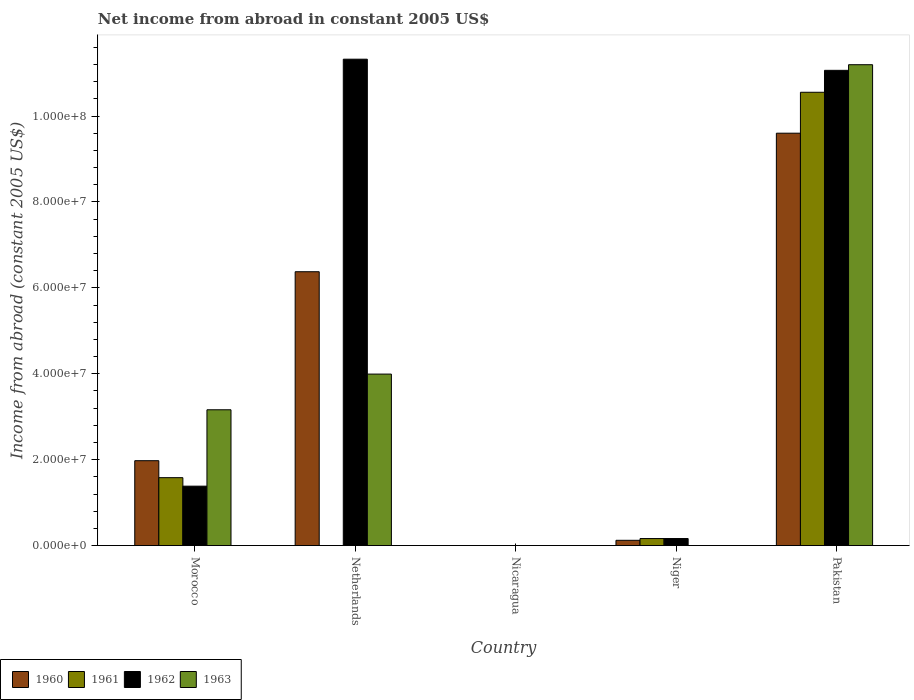Are the number of bars on each tick of the X-axis equal?
Offer a terse response. No. How many bars are there on the 5th tick from the right?
Make the answer very short. 4. In how many cases, is the number of bars for a given country not equal to the number of legend labels?
Make the answer very short. 3. Across all countries, what is the maximum net income from abroad in 1960?
Give a very brief answer. 9.60e+07. In which country was the net income from abroad in 1963 maximum?
Your response must be concise. Pakistan. What is the total net income from abroad in 1962 in the graph?
Make the answer very short. 2.39e+08. What is the difference between the net income from abroad in 1960 in Morocco and that in Niger?
Your response must be concise. 1.85e+07. What is the difference between the net income from abroad in 1962 in Morocco and the net income from abroad in 1963 in Netherlands?
Your response must be concise. -2.61e+07. What is the average net income from abroad in 1962 per country?
Provide a short and direct response. 4.79e+07. What is the difference between the net income from abroad of/in 1963 and net income from abroad of/in 1960 in Pakistan?
Ensure brevity in your answer.  1.59e+07. In how many countries, is the net income from abroad in 1961 greater than 32000000 US$?
Provide a succinct answer. 1. What is the ratio of the net income from abroad in 1960 in Morocco to that in Niger?
Offer a terse response. 16.15. Is the net income from abroad in 1962 in Morocco less than that in Netherlands?
Your answer should be very brief. Yes. Is the difference between the net income from abroad in 1963 in Netherlands and Pakistan greater than the difference between the net income from abroad in 1960 in Netherlands and Pakistan?
Make the answer very short. No. What is the difference between the highest and the second highest net income from abroad in 1962?
Provide a short and direct response. -9.68e+07. What is the difference between the highest and the lowest net income from abroad in 1960?
Give a very brief answer. 9.60e+07. Is the sum of the net income from abroad in 1960 in Netherlands and Niger greater than the maximum net income from abroad in 1961 across all countries?
Your answer should be very brief. No. Is it the case that in every country, the sum of the net income from abroad in 1960 and net income from abroad in 1962 is greater than the sum of net income from abroad in 1963 and net income from abroad in 1961?
Your answer should be very brief. No. Is it the case that in every country, the sum of the net income from abroad in 1963 and net income from abroad in 1960 is greater than the net income from abroad in 1961?
Provide a short and direct response. No. How many bars are there?
Make the answer very short. 14. Are all the bars in the graph horizontal?
Your answer should be compact. No. How many countries are there in the graph?
Offer a terse response. 5. Where does the legend appear in the graph?
Offer a very short reply. Bottom left. What is the title of the graph?
Give a very brief answer. Net income from abroad in constant 2005 US$. What is the label or title of the Y-axis?
Give a very brief answer. Income from abroad (constant 2005 US$). What is the Income from abroad (constant 2005 US$) in 1960 in Morocco?
Give a very brief answer. 1.98e+07. What is the Income from abroad (constant 2005 US$) in 1961 in Morocco?
Your answer should be compact. 1.58e+07. What is the Income from abroad (constant 2005 US$) of 1962 in Morocco?
Provide a succinct answer. 1.38e+07. What is the Income from abroad (constant 2005 US$) of 1963 in Morocco?
Your answer should be compact. 3.16e+07. What is the Income from abroad (constant 2005 US$) in 1960 in Netherlands?
Keep it short and to the point. 6.38e+07. What is the Income from abroad (constant 2005 US$) in 1961 in Netherlands?
Make the answer very short. 0. What is the Income from abroad (constant 2005 US$) in 1962 in Netherlands?
Keep it short and to the point. 1.13e+08. What is the Income from abroad (constant 2005 US$) of 1963 in Netherlands?
Your answer should be very brief. 3.99e+07. What is the Income from abroad (constant 2005 US$) in 1960 in Nicaragua?
Make the answer very short. 0. What is the Income from abroad (constant 2005 US$) of 1961 in Nicaragua?
Your answer should be compact. 0. What is the Income from abroad (constant 2005 US$) in 1960 in Niger?
Your answer should be very brief. 1.22e+06. What is the Income from abroad (constant 2005 US$) in 1961 in Niger?
Offer a terse response. 1.63e+06. What is the Income from abroad (constant 2005 US$) in 1962 in Niger?
Give a very brief answer. 1.64e+06. What is the Income from abroad (constant 2005 US$) of 1963 in Niger?
Keep it short and to the point. 0. What is the Income from abroad (constant 2005 US$) in 1960 in Pakistan?
Ensure brevity in your answer.  9.60e+07. What is the Income from abroad (constant 2005 US$) of 1961 in Pakistan?
Make the answer very short. 1.06e+08. What is the Income from abroad (constant 2005 US$) in 1962 in Pakistan?
Provide a succinct answer. 1.11e+08. What is the Income from abroad (constant 2005 US$) in 1963 in Pakistan?
Your answer should be very brief. 1.12e+08. Across all countries, what is the maximum Income from abroad (constant 2005 US$) of 1960?
Ensure brevity in your answer.  9.60e+07. Across all countries, what is the maximum Income from abroad (constant 2005 US$) of 1961?
Your answer should be compact. 1.06e+08. Across all countries, what is the maximum Income from abroad (constant 2005 US$) of 1962?
Offer a terse response. 1.13e+08. Across all countries, what is the maximum Income from abroad (constant 2005 US$) in 1963?
Offer a terse response. 1.12e+08. Across all countries, what is the minimum Income from abroad (constant 2005 US$) in 1960?
Your answer should be very brief. 0. Across all countries, what is the minimum Income from abroad (constant 2005 US$) in 1962?
Your response must be concise. 0. Across all countries, what is the minimum Income from abroad (constant 2005 US$) of 1963?
Offer a very short reply. 0. What is the total Income from abroad (constant 2005 US$) in 1960 in the graph?
Your answer should be compact. 1.81e+08. What is the total Income from abroad (constant 2005 US$) of 1961 in the graph?
Offer a very short reply. 1.23e+08. What is the total Income from abroad (constant 2005 US$) in 1962 in the graph?
Offer a very short reply. 2.39e+08. What is the total Income from abroad (constant 2005 US$) in 1963 in the graph?
Your answer should be very brief. 1.84e+08. What is the difference between the Income from abroad (constant 2005 US$) in 1960 in Morocco and that in Netherlands?
Ensure brevity in your answer.  -4.40e+07. What is the difference between the Income from abroad (constant 2005 US$) of 1962 in Morocco and that in Netherlands?
Your response must be concise. -9.94e+07. What is the difference between the Income from abroad (constant 2005 US$) of 1963 in Morocco and that in Netherlands?
Your answer should be compact. -8.31e+06. What is the difference between the Income from abroad (constant 2005 US$) of 1960 in Morocco and that in Niger?
Your answer should be very brief. 1.85e+07. What is the difference between the Income from abroad (constant 2005 US$) of 1961 in Morocco and that in Niger?
Keep it short and to the point. 1.42e+07. What is the difference between the Income from abroad (constant 2005 US$) in 1962 in Morocco and that in Niger?
Provide a succinct answer. 1.22e+07. What is the difference between the Income from abroad (constant 2005 US$) of 1960 in Morocco and that in Pakistan?
Provide a succinct answer. -7.63e+07. What is the difference between the Income from abroad (constant 2005 US$) of 1961 in Morocco and that in Pakistan?
Ensure brevity in your answer.  -8.97e+07. What is the difference between the Income from abroad (constant 2005 US$) in 1962 in Morocco and that in Pakistan?
Your answer should be compact. -9.68e+07. What is the difference between the Income from abroad (constant 2005 US$) in 1963 in Morocco and that in Pakistan?
Offer a terse response. -8.03e+07. What is the difference between the Income from abroad (constant 2005 US$) in 1960 in Netherlands and that in Niger?
Keep it short and to the point. 6.25e+07. What is the difference between the Income from abroad (constant 2005 US$) in 1962 in Netherlands and that in Niger?
Ensure brevity in your answer.  1.12e+08. What is the difference between the Income from abroad (constant 2005 US$) of 1960 in Netherlands and that in Pakistan?
Your answer should be compact. -3.23e+07. What is the difference between the Income from abroad (constant 2005 US$) of 1962 in Netherlands and that in Pakistan?
Ensure brevity in your answer.  2.59e+06. What is the difference between the Income from abroad (constant 2005 US$) in 1963 in Netherlands and that in Pakistan?
Offer a very short reply. -7.20e+07. What is the difference between the Income from abroad (constant 2005 US$) in 1960 in Niger and that in Pakistan?
Offer a very short reply. -9.48e+07. What is the difference between the Income from abroad (constant 2005 US$) of 1961 in Niger and that in Pakistan?
Your answer should be very brief. -1.04e+08. What is the difference between the Income from abroad (constant 2005 US$) of 1962 in Niger and that in Pakistan?
Make the answer very short. -1.09e+08. What is the difference between the Income from abroad (constant 2005 US$) in 1960 in Morocco and the Income from abroad (constant 2005 US$) in 1962 in Netherlands?
Offer a terse response. -9.35e+07. What is the difference between the Income from abroad (constant 2005 US$) of 1960 in Morocco and the Income from abroad (constant 2005 US$) of 1963 in Netherlands?
Your response must be concise. -2.02e+07. What is the difference between the Income from abroad (constant 2005 US$) in 1961 in Morocco and the Income from abroad (constant 2005 US$) in 1962 in Netherlands?
Offer a very short reply. -9.74e+07. What is the difference between the Income from abroad (constant 2005 US$) of 1961 in Morocco and the Income from abroad (constant 2005 US$) of 1963 in Netherlands?
Provide a succinct answer. -2.41e+07. What is the difference between the Income from abroad (constant 2005 US$) of 1962 in Morocco and the Income from abroad (constant 2005 US$) of 1963 in Netherlands?
Provide a succinct answer. -2.61e+07. What is the difference between the Income from abroad (constant 2005 US$) of 1960 in Morocco and the Income from abroad (constant 2005 US$) of 1961 in Niger?
Keep it short and to the point. 1.81e+07. What is the difference between the Income from abroad (constant 2005 US$) of 1960 in Morocco and the Income from abroad (constant 2005 US$) of 1962 in Niger?
Your response must be concise. 1.81e+07. What is the difference between the Income from abroad (constant 2005 US$) of 1961 in Morocco and the Income from abroad (constant 2005 US$) of 1962 in Niger?
Keep it short and to the point. 1.42e+07. What is the difference between the Income from abroad (constant 2005 US$) in 1960 in Morocco and the Income from abroad (constant 2005 US$) in 1961 in Pakistan?
Give a very brief answer. -8.58e+07. What is the difference between the Income from abroad (constant 2005 US$) of 1960 in Morocco and the Income from abroad (constant 2005 US$) of 1962 in Pakistan?
Offer a terse response. -9.09e+07. What is the difference between the Income from abroad (constant 2005 US$) of 1960 in Morocco and the Income from abroad (constant 2005 US$) of 1963 in Pakistan?
Give a very brief answer. -9.22e+07. What is the difference between the Income from abroad (constant 2005 US$) of 1961 in Morocco and the Income from abroad (constant 2005 US$) of 1962 in Pakistan?
Provide a short and direct response. -9.48e+07. What is the difference between the Income from abroad (constant 2005 US$) in 1961 in Morocco and the Income from abroad (constant 2005 US$) in 1963 in Pakistan?
Give a very brief answer. -9.62e+07. What is the difference between the Income from abroad (constant 2005 US$) in 1962 in Morocco and the Income from abroad (constant 2005 US$) in 1963 in Pakistan?
Give a very brief answer. -9.81e+07. What is the difference between the Income from abroad (constant 2005 US$) of 1960 in Netherlands and the Income from abroad (constant 2005 US$) of 1961 in Niger?
Provide a short and direct response. 6.21e+07. What is the difference between the Income from abroad (constant 2005 US$) in 1960 in Netherlands and the Income from abroad (constant 2005 US$) in 1962 in Niger?
Your answer should be compact. 6.21e+07. What is the difference between the Income from abroad (constant 2005 US$) in 1960 in Netherlands and the Income from abroad (constant 2005 US$) in 1961 in Pakistan?
Ensure brevity in your answer.  -4.18e+07. What is the difference between the Income from abroad (constant 2005 US$) of 1960 in Netherlands and the Income from abroad (constant 2005 US$) of 1962 in Pakistan?
Ensure brevity in your answer.  -4.69e+07. What is the difference between the Income from abroad (constant 2005 US$) in 1960 in Netherlands and the Income from abroad (constant 2005 US$) in 1963 in Pakistan?
Make the answer very short. -4.82e+07. What is the difference between the Income from abroad (constant 2005 US$) of 1962 in Netherlands and the Income from abroad (constant 2005 US$) of 1963 in Pakistan?
Your answer should be very brief. 1.29e+06. What is the difference between the Income from abroad (constant 2005 US$) of 1960 in Niger and the Income from abroad (constant 2005 US$) of 1961 in Pakistan?
Your response must be concise. -1.04e+08. What is the difference between the Income from abroad (constant 2005 US$) of 1960 in Niger and the Income from abroad (constant 2005 US$) of 1962 in Pakistan?
Your answer should be compact. -1.09e+08. What is the difference between the Income from abroad (constant 2005 US$) in 1960 in Niger and the Income from abroad (constant 2005 US$) in 1963 in Pakistan?
Keep it short and to the point. -1.11e+08. What is the difference between the Income from abroad (constant 2005 US$) in 1961 in Niger and the Income from abroad (constant 2005 US$) in 1962 in Pakistan?
Provide a succinct answer. -1.09e+08. What is the difference between the Income from abroad (constant 2005 US$) in 1961 in Niger and the Income from abroad (constant 2005 US$) in 1963 in Pakistan?
Provide a short and direct response. -1.10e+08. What is the difference between the Income from abroad (constant 2005 US$) in 1962 in Niger and the Income from abroad (constant 2005 US$) in 1963 in Pakistan?
Your response must be concise. -1.10e+08. What is the average Income from abroad (constant 2005 US$) in 1960 per country?
Your response must be concise. 3.62e+07. What is the average Income from abroad (constant 2005 US$) in 1961 per country?
Your response must be concise. 2.46e+07. What is the average Income from abroad (constant 2005 US$) in 1962 per country?
Your response must be concise. 4.79e+07. What is the average Income from abroad (constant 2005 US$) in 1963 per country?
Give a very brief answer. 3.67e+07. What is the difference between the Income from abroad (constant 2005 US$) in 1960 and Income from abroad (constant 2005 US$) in 1961 in Morocco?
Ensure brevity in your answer.  3.95e+06. What is the difference between the Income from abroad (constant 2005 US$) of 1960 and Income from abroad (constant 2005 US$) of 1962 in Morocco?
Keep it short and to the point. 5.93e+06. What is the difference between the Income from abroad (constant 2005 US$) in 1960 and Income from abroad (constant 2005 US$) in 1963 in Morocco?
Offer a very short reply. -1.19e+07. What is the difference between the Income from abroad (constant 2005 US$) in 1961 and Income from abroad (constant 2005 US$) in 1962 in Morocco?
Offer a very short reply. 1.98e+06. What is the difference between the Income from abroad (constant 2005 US$) in 1961 and Income from abroad (constant 2005 US$) in 1963 in Morocco?
Ensure brevity in your answer.  -1.58e+07. What is the difference between the Income from abroad (constant 2005 US$) of 1962 and Income from abroad (constant 2005 US$) of 1963 in Morocco?
Keep it short and to the point. -1.78e+07. What is the difference between the Income from abroad (constant 2005 US$) of 1960 and Income from abroad (constant 2005 US$) of 1962 in Netherlands?
Your answer should be very brief. -4.95e+07. What is the difference between the Income from abroad (constant 2005 US$) in 1960 and Income from abroad (constant 2005 US$) in 1963 in Netherlands?
Keep it short and to the point. 2.38e+07. What is the difference between the Income from abroad (constant 2005 US$) in 1962 and Income from abroad (constant 2005 US$) in 1963 in Netherlands?
Your answer should be compact. 7.33e+07. What is the difference between the Income from abroad (constant 2005 US$) of 1960 and Income from abroad (constant 2005 US$) of 1961 in Niger?
Ensure brevity in your answer.  -4.08e+05. What is the difference between the Income from abroad (constant 2005 US$) of 1960 and Income from abroad (constant 2005 US$) of 1962 in Niger?
Provide a succinct answer. -4.13e+05. What is the difference between the Income from abroad (constant 2005 US$) in 1961 and Income from abroad (constant 2005 US$) in 1962 in Niger?
Offer a terse response. -5017.31. What is the difference between the Income from abroad (constant 2005 US$) of 1960 and Income from abroad (constant 2005 US$) of 1961 in Pakistan?
Give a very brief answer. -9.53e+06. What is the difference between the Income from abroad (constant 2005 US$) of 1960 and Income from abroad (constant 2005 US$) of 1962 in Pakistan?
Make the answer very short. -1.46e+07. What is the difference between the Income from abroad (constant 2005 US$) in 1960 and Income from abroad (constant 2005 US$) in 1963 in Pakistan?
Provide a short and direct response. -1.59e+07. What is the difference between the Income from abroad (constant 2005 US$) in 1961 and Income from abroad (constant 2005 US$) in 1962 in Pakistan?
Offer a very short reply. -5.11e+06. What is the difference between the Income from abroad (constant 2005 US$) of 1961 and Income from abroad (constant 2005 US$) of 1963 in Pakistan?
Provide a succinct answer. -6.42e+06. What is the difference between the Income from abroad (constant 2005 US$) in 1962 and Income from abroad (constant 2005 US$) in 1963 in Pakistan?
Provide a succinct answer. -1.31e+06. What is the ratio of the Income from abroad (constant 2005 US$) in 1960 in Morocco to that in Netherlands?
Provide a succinct answer. 0.31. What is the ratio of the Income from abroad (constant 2005 US$) in 1962 in Morocco to that in Netherlands?
Provide a succinct answer. 0.12. What is the ratio of the Income from abroad (constant 2005 US$) in 1963 in Morocco to that in Netherlands?
Your response must be concise. 0.79. What is the ratio of the Income from abroad (constant 2005 US$) in 1960 in Morocco to that in Niger?
Keep it short and to the point. 16.15. What is the ratio of the Income from abroad (constant 2005 US$) in 1961 in Morocco to that in Niger?
Offer a terse response. 9.69. What is the ratio of the Income from abroad (constant 2005 US$) in 1962 in Morocco to that in Niger?
Offer a very short reply. 8.45. What is the ratio of the Income from abroad (constant 2005 US$) in 1960 in Morocco to that in Pakistan?
Provide a short and direct response. 0.21. What is the ratio of the Income from abroad (constant 2005 US$) of 1961 in Morocco to that in Pakistan?
Give a very brief answer. 0.15. What is the ratio of the Income from abroad (constant 2005 US$) of 1962 in Morocco to that in Pakistan?
Make the answer very short. 0.12. What is the ratio of the Income from abroad (constant 2005 US$) of 1963 in Morocco to that in Pakistan?
Make the answer very short. 0.28. What is the ratio of the Income from abroad (constant 2005 US$) of 1960 in Netherlands to that in Niger?
Your answer should be very brief. 52.1. What is the ratio of the Income from abroad (constant 2005 US$) of 1962 in Netherlands to that in Niger?
Offer a very short reply. 69.18. What is the ratio of the Income from abroad (constant 2005 US$) of 1960 in Netherlands to that in Pakistan?
Ensure brevity in your answer.  0.66. What is the ratio of the Income from abroad (constant 2005 US$) of 1962 in Netherlands to that in Pakistan?
Your answer should be compact. 1.02. What is the ratio of the Income from abroad (constant 2005 US$) of 1963 in Netherlands to that in Pakistan?
Your answer should be compact. 0.36. What is the ratio of the Income from abroad (constant 2005 US$) of 1960 in Niger to that in Pakistan?
Give a very brief answer. 0.01. What is the ratio of the Income from abroad (constant 2005 US$) of 1961 in Niger to that in Pakistan?
Your answer should be compact. 0.02. What is the ratio of the Income from abroad (constant 2005 US$) of 1962 in Niger to that in Pakistan?
Ensure brevity in your answer.  0.01. What is the difference between the highest and the second highest Income from abroad (constant 2005 US$) in 1960?
Make the answer very short. 3.23e+07. What is the difference between the highest and the second highest Income from abroad (constant 2005 US$) in 1961?
Your response must be concise. 8.97e+07. What is the difference between the highest and the second highest Income from abroad (constant 2005 US$) of 1962?
Your response must be concise. 2.59e+06. What is the difference between the highest and the second highest Income from abroad (constant 2005 US$) of 1963?
Provide a succinct answer. 7.20e+07. What is the difference between the highest and the lowest Income from abroad (constant 2005 US$) in 1960?
Keep it short and to the point. 9.60e+07. What is the difference between the highest and the lowest Income from abroad (constant 2005 US$) of 1961?
Provide a succinct answer. 1.06e+08. What is the difference between the highest and the lowest Income from abroad (constant 2005 US$) of 1962?
Make the answer very short. 1.13e+08. What is the difference between the highest and the lowest Income from abroad (constant 2005 US$) in 1963?
Ensure brevity in your answer.  1.12e+08. 